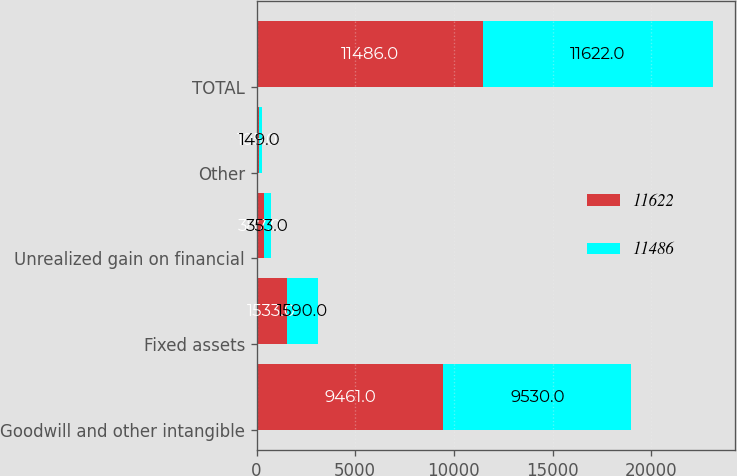Convert chart to OTSL. <chart><loc_0><loc_0><loc_500><loc_500><stacked_bar_chart><ecel><fcel>Goodwill and other intangible<fcel>Fixed assets<fcel>Unrealized gain on financial<fcel>Other<fcel>TOTAL<nl><fcel>11622<fcel>9461<fcel>1533<fcel>387<fcel>105<fcel>11486<nl><fcel>11486<fcel>9530<fcel>1590<fcel>353<fcel>149<fcel>11622<nl></chart> 